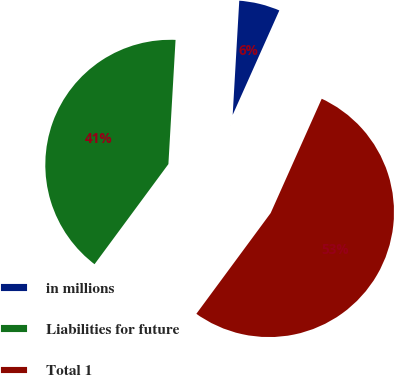Convert chart. <chart><loc_0><loc_0><loc_500><loc_500><pie_chart><fcel>in millions<fcel>Liabilities for future<fcel>Total 1<nl><fcel>5.77%<fcel>40.8%<fcel>53.43%<nl></chart> 